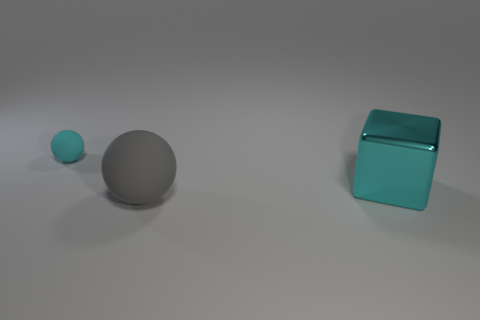Do the ball that is behind the large metallic block and the block have the same color?
Ensure brevity in your answer.  Yes. Is there anything else that is the same material as the gray sphere?
Give a very brief answer. Yes. How many other cyan rubber objects have the same shape as the cyan rubber thing?
Your answer should be very brief. 0. The ball that is made of the same material as the small object is what size?
Your response must be concise. Large. Are there any gray matte balls that are on the left side of the matte thing that is in front of the object that is behind the cyan metal cube?
Provide a succinct answer. No. Do the sphere that is on the left side of the gray thing and the big gray rubber thing have the same size?
Offer a terse response. No. What number of objects are the same size as the cyan block?
Provide a succinct answer. 1. The metallic object that is the same color as the tiny ball is what size?
Provide a succinct answer. Large. Do the big metal object and the small rubber thing have the same color?
Make the answer very short. Yes. What is the shape of the cyan rubber object?
Give a very brief answer. Sphere. 